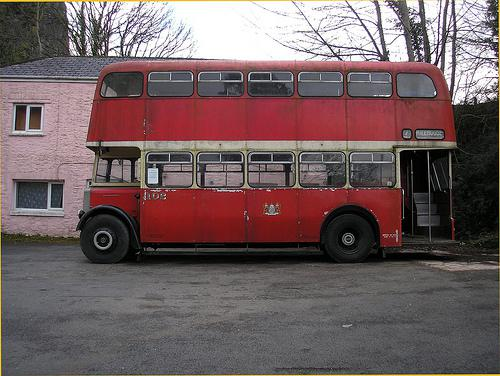Question: where is the picture taken?
Choices:
A. In a shopping center.
B. In a parking lot.
C. Near a building.
D. Outside a store.
Answer with the letter. Answer: B Question: what is seen?
Choices:
A. Car.
B. Plane.
C. Bike.
D. Bus.
Answer with the letter. Answer: D Question: what is the color of the bus?
Choices:
A. White.
B. Red.
C. Blue.
D. Green.
Answer with the letter. Answer: B Question: what is the color of the building?
Choices:
A. Pink.
B. Orange.
C. Purple.
D. Yellow.
Answer with the letter. Answer: A Question: what is the color of the road?
Choices:
A. Brown.
B. Grey.
C. White.
D. Black.
Answer with the letter. Answer: B 